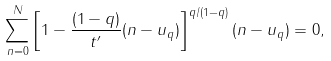Convert formula to latex. <formula><loc_0><loc_0><loc_500><loc_500>\sum _ { n = 0 } ^ { N } \left [ 1 - \frac { ( 1 - q ) } { t ^ { \prime } } ( n - u _ { q } ) \right ] ^ { q / ( 1 - q ) } ( n - u _ { q } ) = 0 ,</formula> 